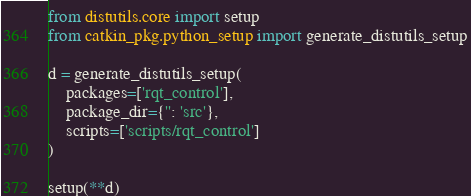Convert code to text. <code><loc_0><loc_0><loc_500><loc_500><_Python_>from distutils.core import setup
from catkin_pkg.python_setup import generate_distutils_setup

d = generate_distutils_setup(
    packages=['rqt_control'],
    package_dir={'': 'src'},
    scripts=['scripts/rqt_control']
)

setup(**d)
</code> 